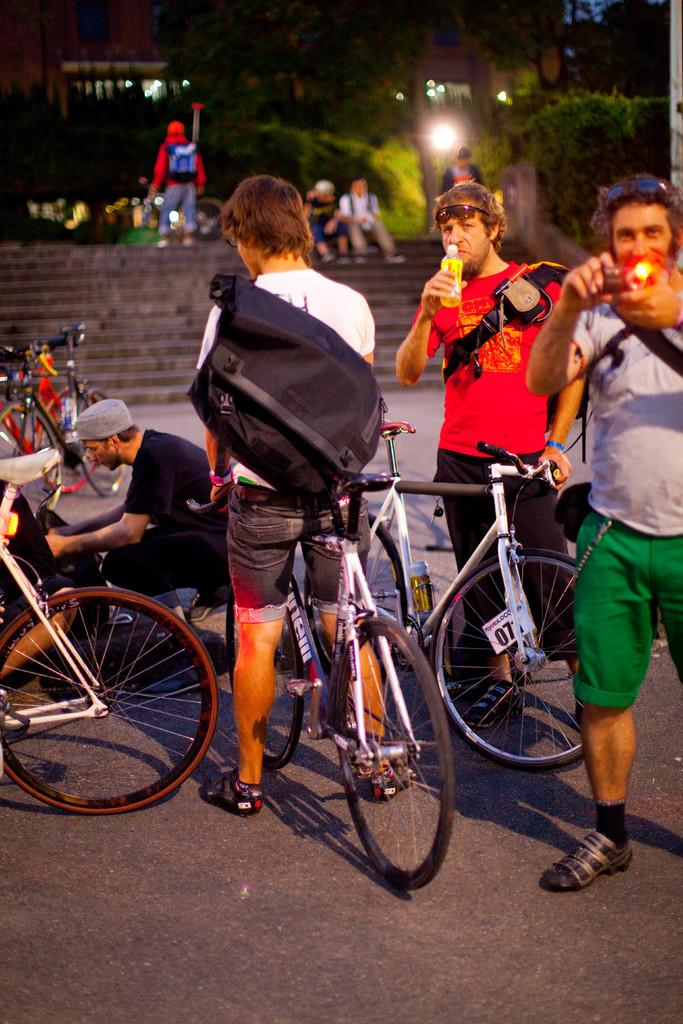How many people are in the image? There is a group of people in the image. What are the people in the image doing? The people are standing. Can you describe any specific object being held by one of the people? Yes, there is a man holding a bicycle in the image. What type of ring can be seen on the man's finger in the image? There is no ring visible on the man's finger in the image. Is there any sleet falling in the image? There is no mention of sleet or any weather condition in the image. Can you see a gun being held by any of the people in the image? There is no gun present in the image. 